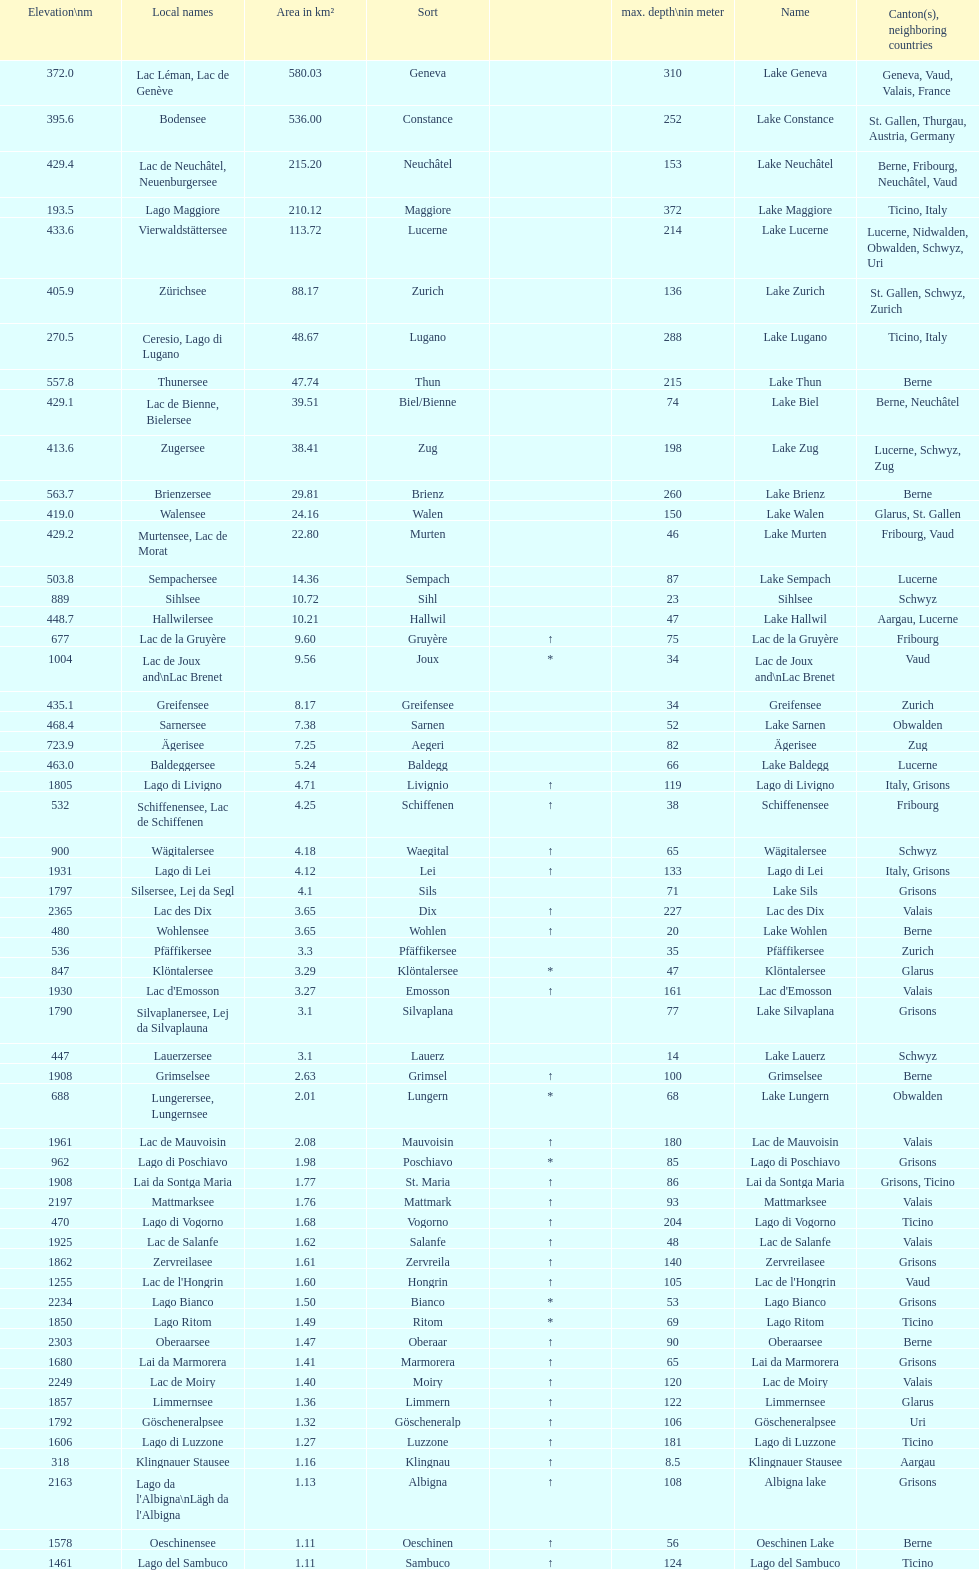What is the total area in km² of lake sils? 4.1. I'm looking to parse the entire table for insights. Could you assist me with that? {'header': ['Elevation\\nm', 'Local names', 'Area in km²', 'Sort', '', 'max. depth\\nin meter', 'Name', 'Canton(s), neighboring countries'], 'rows': [['372.0', 'Lac Léman, Lac de Genève', '580.03', 'Geneva', '', '310', 'Lake Geneva', 'Geneva, Vaud, Valais, France'], ['395.6', 'Bodensee', '536.00', 'Constance', '', '252', 'Lake Constance', 'St. Gallen, Thurgau, Austria, Germany'], ['429.4', 'Lac de Neuchâtel, Neuenburgersee', '215.20', 'Neuchâtel', '', '153', 'Lake Neuchâtel', 'Berne, Fribourg, Neuchâtel, Vaud'], ['193.5', 'Lago Maggiore', '210.12', 'Maggiore', '', '372', 'Lake Maggiore', 'Ticino, Italy'], ['433.6', 'Vierwaldstättersee', '113.72', 'Lucerne', '', '214', 'Lake Lucerne', 'Lucerne, Nidwalden, Obwalden, Schwyz, Uri'], ['405.9', 'Zürichsee', '88.17', 'Zurich', '', '136', 'Lake Zurich', 'St. Gallen, Schwyz, Zurich'], ['270.5', 'Ceresio, Lago di Lugano', '48.67', 'Lugano', '', '288', 'Lake Lugano', 'Ticino, Italy'], ['557.8', 'Thunersee', '47.74', 'Thun', '', '215', 'Lake Thun', 'Berne'], ['429.1', 'Lac de Bienne, Bielersee', '39.51', 'Biel/Bienne', '', '74', 'Lake Biel', 'Berne, Neuchâtel'], ['413.6', 'Zugersee', '38.41', 'Zug', '', '198', 'Lake Zug', 'Lucerne, Schwyz, Zug'], ['563.7', 'Brienzersee', '29.81', 'Brienz', '', '260', 'Lake Brienz', 'Berne'], ['419.0', 'Walensee', '24.16', 'Walen', '', '150', 'Lake Walen', 'Glarus, St. Gallen'], ['429.2', 'Murtensee, Lac de Morat', '22.80', 'Murten', '', '46', 'Lake Murten', 'Fribourg, Vaud'], ['503.8', 'Sempachersee', '14.36', 'Sempach', '', '87', 'Lake Sempach', 'Lucerne'], ['889', 'Sihlsee', '10.72', 'Sihl', '', '23', 'Sihlsee', 'Schwyz'], ['448.7', 'Hallwilersee', '10.21', 'Hallwil', '', '47', 'Lake Hallwil', 'Aargau, Lucerne'], ['677', 'Lac de la Gruyère', '9.60', 'Gruyère', '↑', '75', 'Lac de la Gruyère', 'Fribourg'], ['1004', 'Lac de Joux and\\nLac Brenet', '9.56', 'Joux', '*', '34', 'Lac de Joux and\\nLac Brenet', 'Vaud'], ['435.1', 'Greifensee', '8.17', 'Greifensee', '', '34', 'Greifensee', 'Zurich'], ['468.4', 'Sarnersee', '7.38', 'Sarnen', '', '52', 'Lake Sarnen', 'Obwalden'], ['723.9', 'Ägerisee', '7.25', 'Aegeri', '', '82', 'Ägerisee', 'Zug'], ['463.0', 'Baldeggersee', '5.24', 'Baldegg', '', '66', 'Lake Baldegg', 'Lucerne'], ['1805', 'Lago di Livigno', '4.71', 'Livignio', '↑', '119', 'Lago di Livigno', 'Italy, Grisons'], ['532', 'Schiffenensee, Lac de Schiffenen', '4.25', 'Schiffenen', '↑', '38', 'Schiffenensee', 'Fribourg'], ['900', 'Wägitalersee', '4.18', 'Waegital', '↑', '65', 'Wägitalersee', 'Schwyz'], ['1931', 'Lago di Lei', '4.12', 'Lei', '↑', '133', 'Lago di Lei', 'Italy, Grisons'], ['1797', 'Silsersee, Lej da Segl', '4.1', 'Sils', '', '71', 'Lake Sils', 'Grisons'], ['2365', 'Lac des Dix', '3.65', 'Dix', '↑', '227', 'Lac des Dix', 'Valais'], ['480', 'Wohlensee', '3.65', 'Wohlen', '↑', '20', 'Lake Wohlen', 'Berne'], ['536', 'Pfäffikersee', '3.3', 'Pfäffikersee', '', '35', 'Pfäffikersee', 'Zurich'], ['847', 'Klöntalersee', '3.29', 'Klöntalersee', '*', '47', 'Klöntalersee', 'Glarus'], ['1930', "Lac d'Emosson", '3.27', 'Emosson', '↑', '161', "Lac d'Emosson", 'Valais'], ['1790', 'Silvaplanersee, Lej da Silvaplauna', '3.1', 'Silvaplana', '', '77', 'Lake Silvaplana', 'Grisons'], ['447', 'Lauerzersee', '3.1', 'Lauerz', '', '14', 'Lake Lauerz', 'Schwyz'], ['1908', 'Grimselsee', '2.63', 'Grimsel', '↑', '100', 'Grimselsee', 'Berne'], ['688', 'Lungerersee, Lungernsee', '2.01', 'Lungern', '*', '68', 'Lake Lungern', 'Obwalden'], ['1961', 'Lac de Mauvoisin', '2.08', 'Mauvoisin', '↑', '180', 'Lac de Mauvoisin', 'Valais'], ['962', 'Lago di Poschiavo', '1.98', 'Poschiavo', '*', '85', 'Lago di Poschiavo', 'Grisons'], ['1908', 'Lai da Sontga Maria', '1.77', 'St. Maria', '↑', '86', 'Lai da Sontga Maria', 'Grisons, Ticino'], ['2197', 'Mattmarksee', '1.76', 'Mattmark', '↑', '93', 'Mattmarksee', 'Valais'], ['470', 'Lago di Vogorno', '1.68', 'Vogorno', '↑', '204', 'Lago di Vogorno', 'Ticino'], ['1925', 'Lac de Salanfe', '1.62', 'Salanfe', '↑', '48', 'Lac de Salanfe', 'Valais'], ['1862', 'Zervreilasee', '1.61', 'Zervreila', '↑', '140', 'Zervreilasee', 'Grisons'], ['1255', "Lac de l'Hongrin", '1.60', 'Hongrin', '↑', '105', "Lac de l'Hongrin", 'Vaud'], ['2234', 'Lago Bianco', '1.50', 'Bianco', '*', '53', 'Lago Bianco', 'Grisons'], ['1850', 'Lago Ritom', '1.49', 'Ritom', '*', '69', 'Lago Ritom', 'Ticino'], ['2303', 'Oberaarsee', '1.47', 'Oberaar', '↑', '90', 'Oberaarsee', 'Berne'], ['1680', 'Lai da Marmorera', '1.41', 'Marmorera', '↑', '65', 'Lai da Marmorera', 'Grisons'], ['2249', 'Lac de Moiry', '1.40', 'Moiry', '↑', '120', 'Lac de Moiry', 'Valais'], ['1857', 'Limmernsee', '1.36', 'Limmern', '↑', '122', 'Limmernsee', 'Glarus'], ['1792', 'Göscheneralpsee', '1.32', 'Göscheneralp', '↑', '106', 'Göscheneralpsee', 'Uri'], ['1606', 'Lago di Luzzone', '1.27', 'Luzzone', '↑', '181', 'Lago di Luzzone', 'Ticino'], ['318', 'Klingnauer Stausee', '1.16', 'Klingnau', '↑', '8.5', 'Klingnauer Stausee', 'Aargau'], ['2163', "Lago da l'Albigna\\nLägh da l'Albigna", '1.13', 'Albigna', '↑', '108', 'Albigna lake', 'Grisons'], ['1578', 'Oeschinensee', '1.11', 'Oeschinen', '↑', '56', 'Oeschinen Lake', 'Berne'], ['1461', 'Lago del Sambuco', '1.11', 'Sambuco', '↑', '124', 'Lago del Sambuco', 'Ticino']]} 